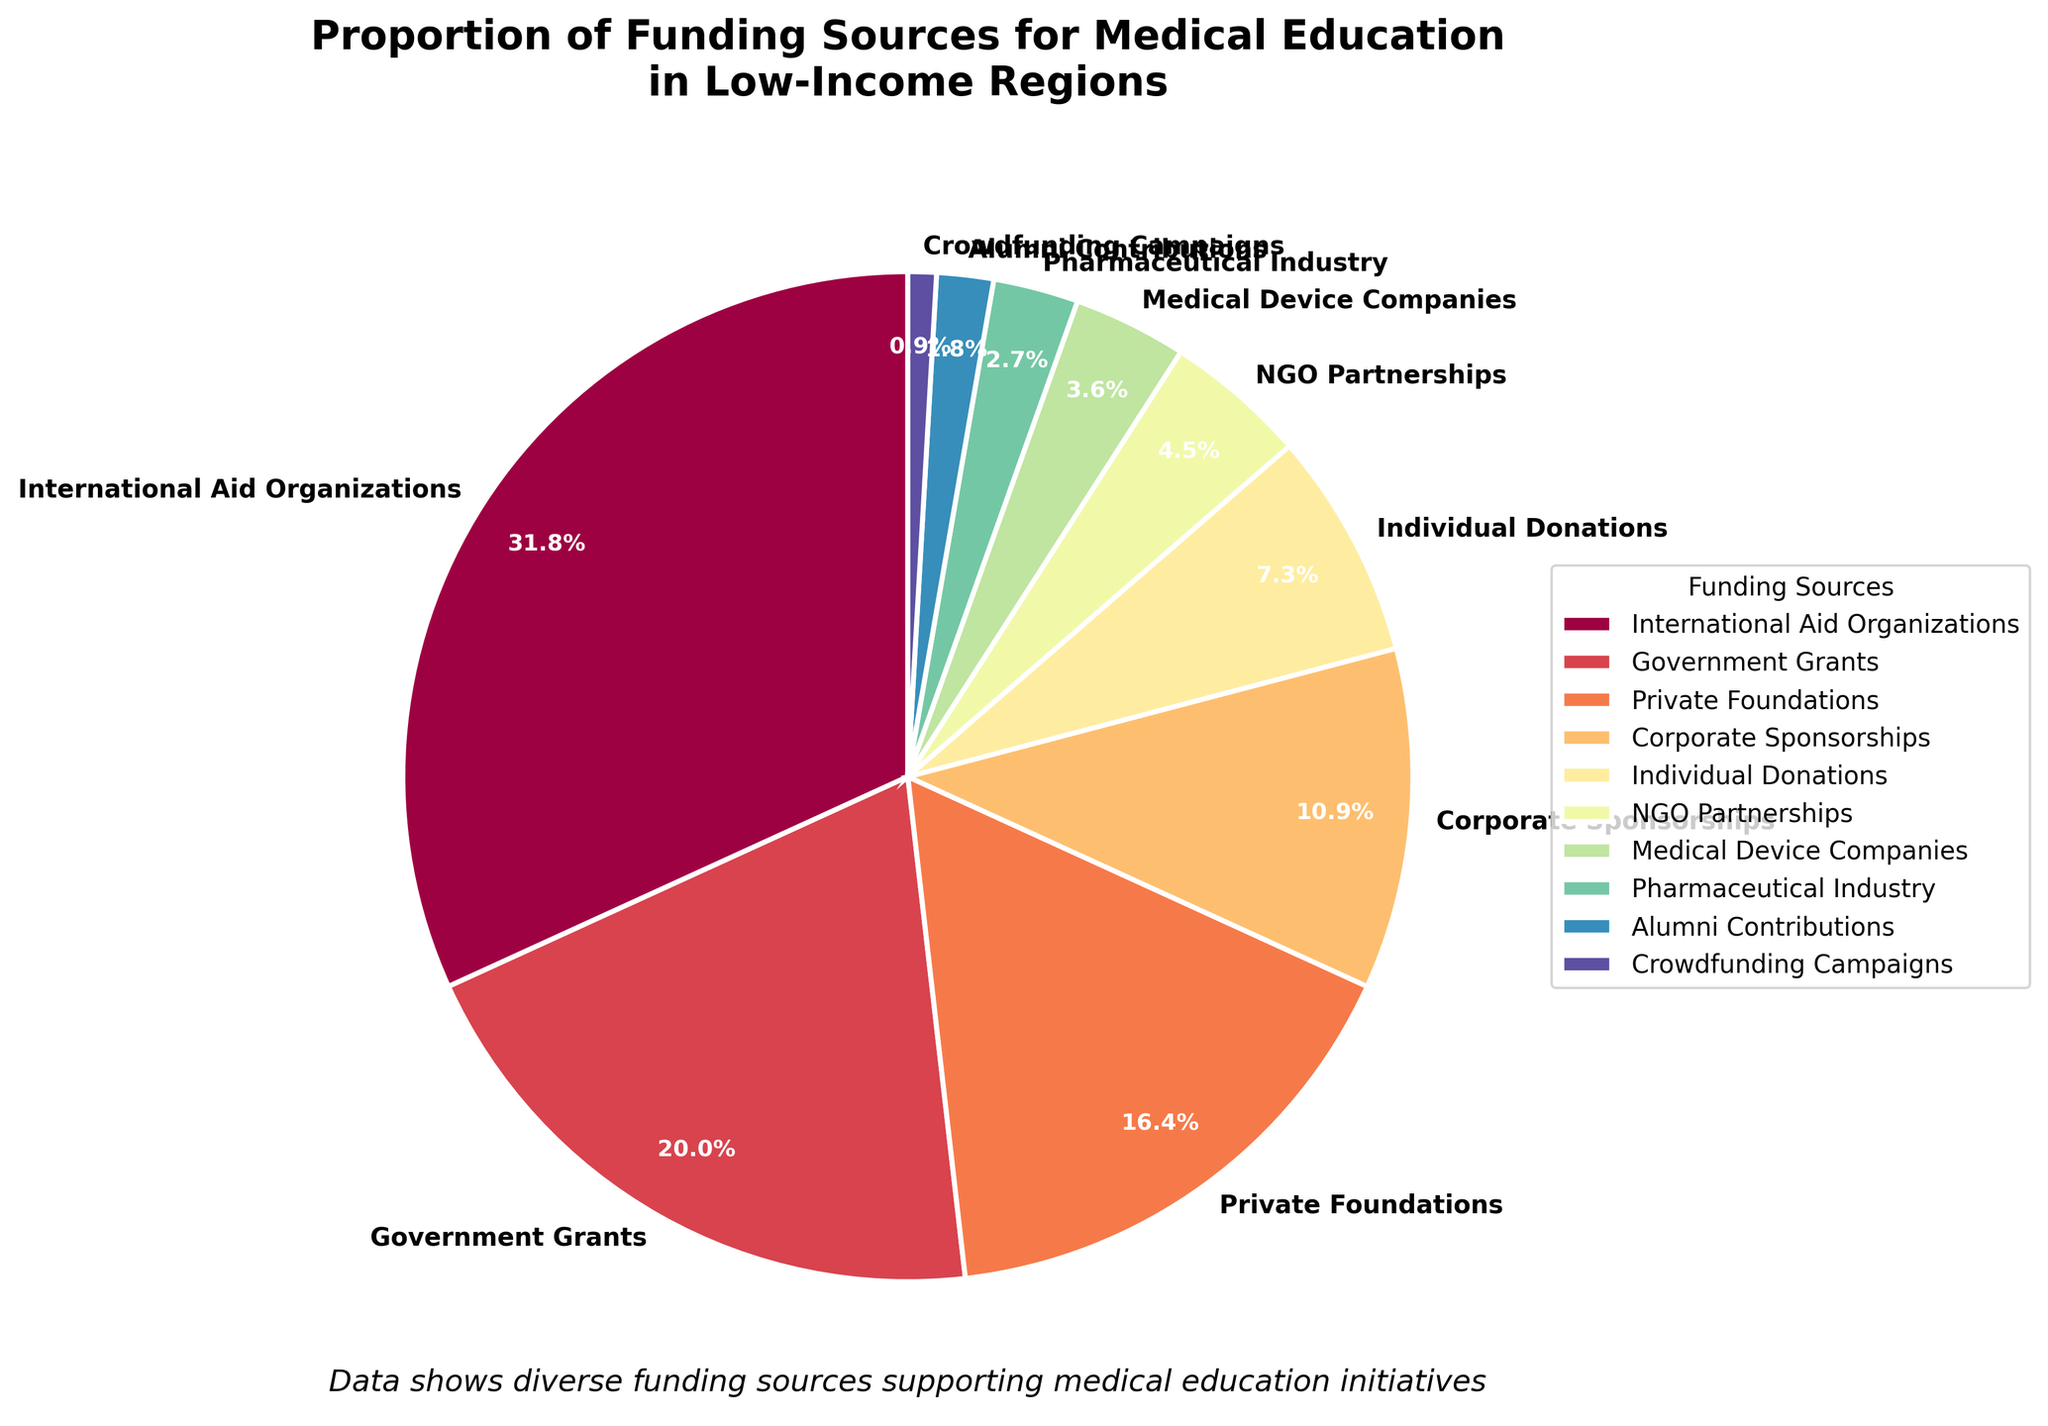What funding source contributes the highest proportion? Observe the pie chart to find the sector with the largest percentage. The largest segment corresponds to "International Aid Organizations" with 35%.
Answer: International Aid Organizations Which funding sources contribute more than 20%? Locate the segments in the pie chart that have percentages greater than 20%. "International Aid Organizations" (35%) and "Government Grants" (22%) fit this criterion.
Answer: International Aid Organizations, Government Grants What is the combined percentage contribution of Individual Donations and Crowdfunding Campaigns? Find the segments for "Individual Donations" and "Crowdfunding Campaigns," then sum their percentages, i.e., 8% + 1%.
Answer: 9% How does the contribution of Private Foundations compare to Corporate Sponsorships? Look at the segments for "Private Foundations" (18%) and "Corporate Sponsorships" (12%). Calculate the difference: 18% - 12%.
Answer: 6% more Which sector provides the smallest contribution, and what is its percentage? Identify the tiniest segment in the pie chart, which is "Crowdfunding Campaigns" at 1%.
Answer: Crowdfunding Campaigns, 1% What is the total contribution of all "Medical-related" funding sources (Medical Device Companies and Pharmaceutical Industry)? Locate and sum the segments for "Medical Device Companies" (4%) and "Pharmaceutical Industry" (3%).
Answer: 7% What percentage of the funding comes from organizations (NGO Partnerships, International Aid Organizations, and Government Grants)? Sum the segment percentages of "NGO Partnerships" (5%), "International Aid Organizations" (35%), and "Government Grants" (22%). The total is 5% + 35% + 22%.
Answer: 62% Identify the sectors with a contribution lower than 5%. Check the pie chart for segments under 5%, which includes "Crowdfunding Campaigns" (1%), "Alumni Contributions" (2%), "Medical Device Companies" (4%), and "Pharmaceutical Industry" (3%).
Answer: Crowdfunding Campaigns, Alumni Contributions, Medical Device Companies, Pharmaceutical Industry Compare the contributions of Government Grants and Private Foundations. Observe the pie chart where "Government Grants" contribute 22% and "Private Foundations" contribute 18%. The difference is 22% - 18%.
Answer: Government Grants contribute 4% more What is the difference in percentage between the highest and lowest contributing sources? The highest contributor is "International Aid Organizations" (35%) and the lowest is "Crowdfunding Campaigns" (1%). Calculate the difference: 35% - 1%.
Answer: 34% 